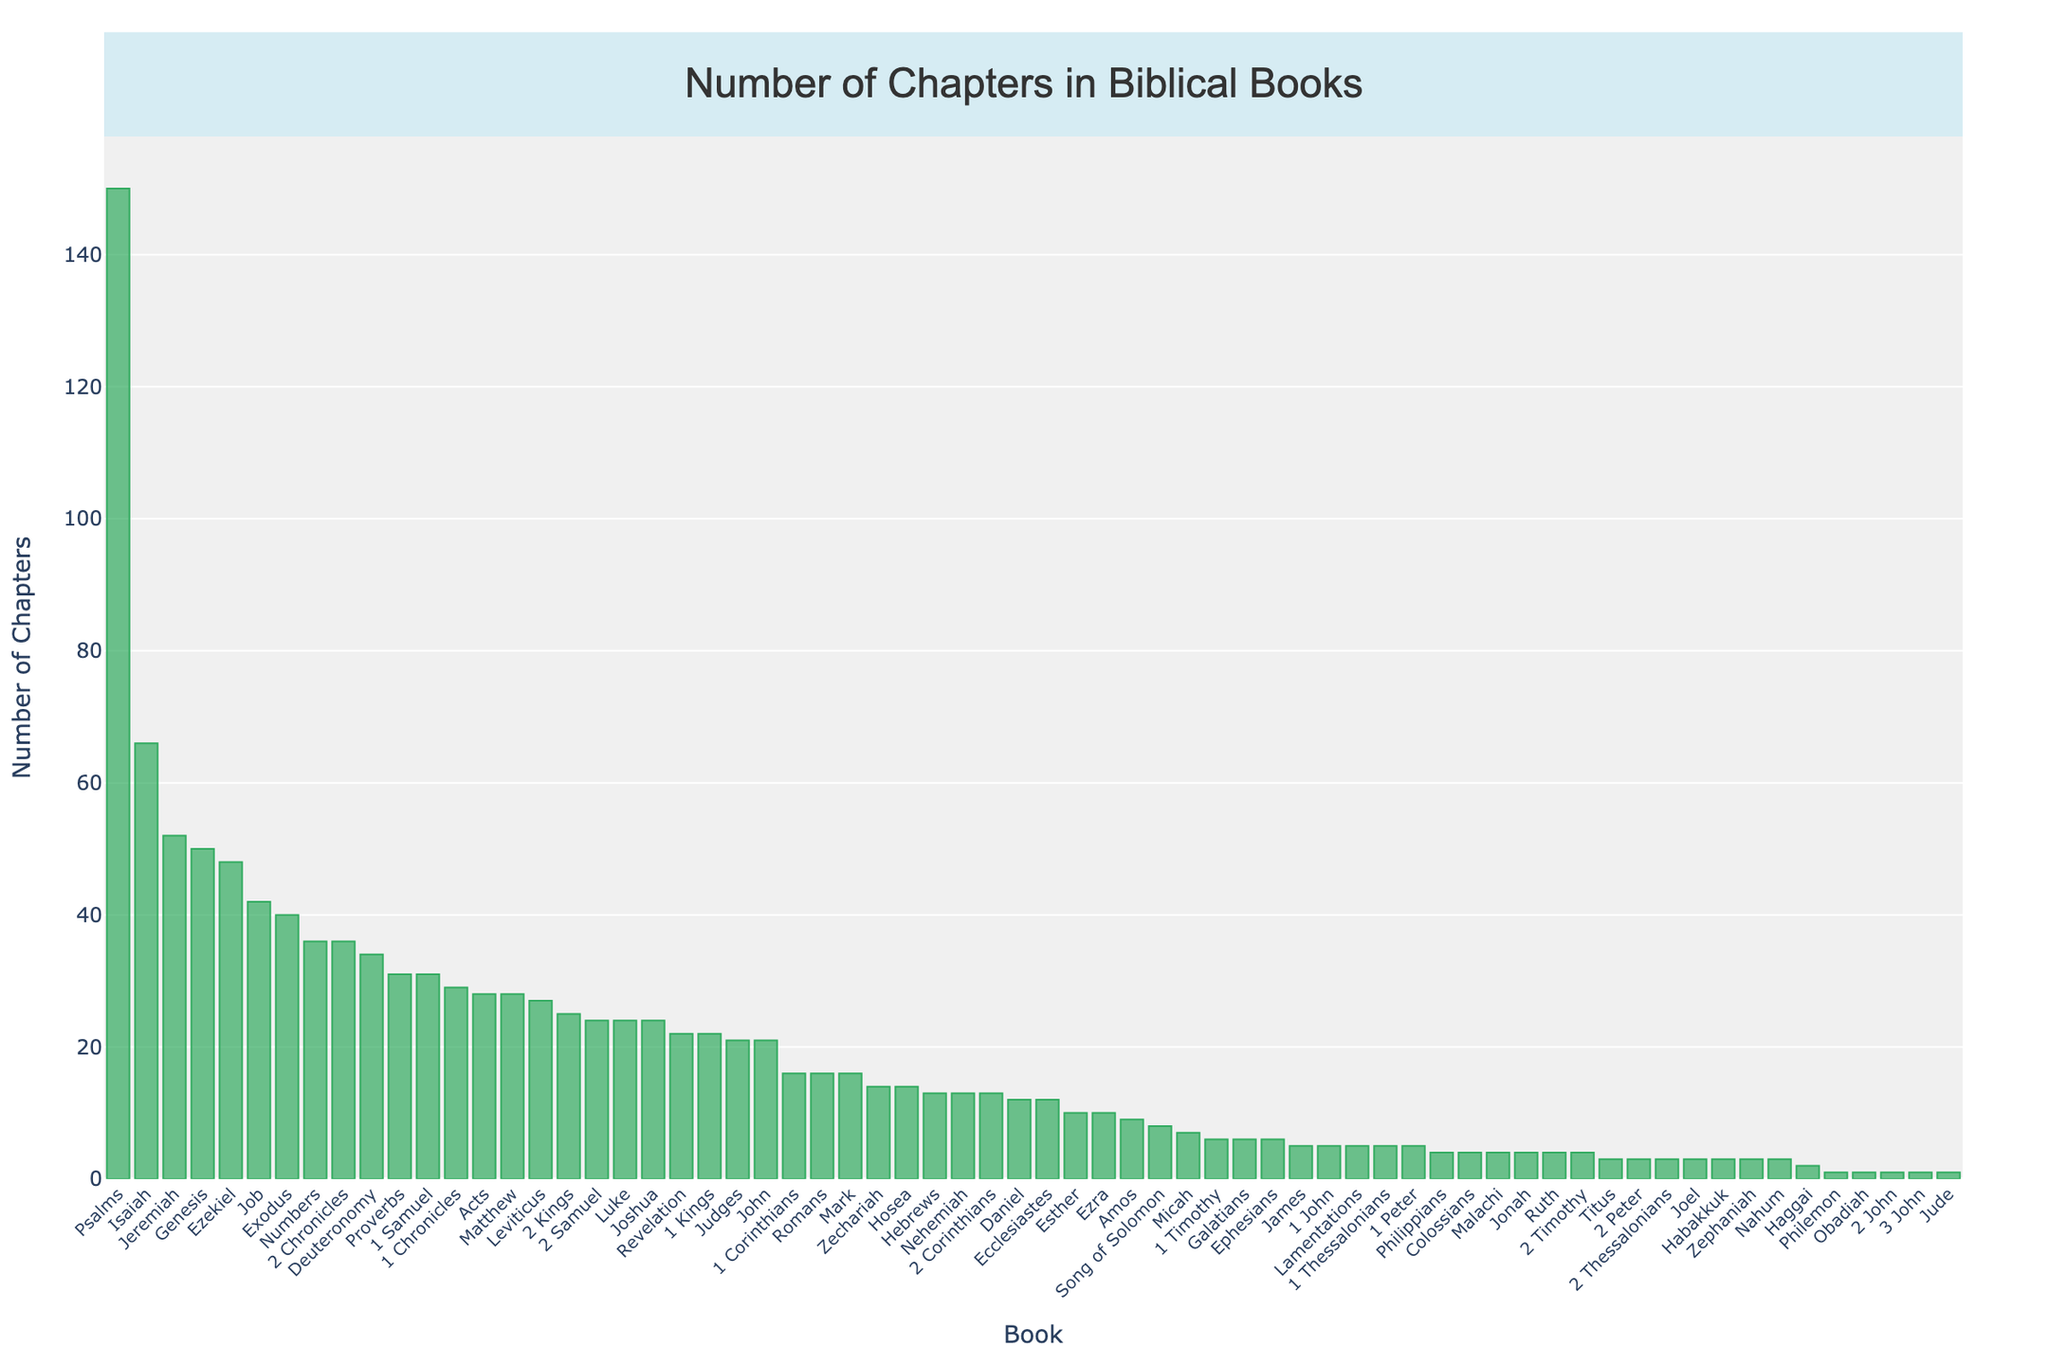Which book has the highest number of chapters? Looking at the highest bar in the chart, we identify Psalms as the book with the largest number of chapters, which is 150.
Answer: Psalms Which book has more chapters, Isaiah or Jeremiah? Compare the heights of the bars for Isaiah and Jeremiah. Isaiah has 66 chapters, and Jeremiah has 52 chapters. Therefore, Isaiah has more chapters.
Answer: Isaiah How many books have more than 40 chapters? Count the bars that have a height representing more than 40 chapters. The books are Genesis, Exodus, Job, Isaiah, Jeremiah, Ezekiel, and Psalms, making a total of 7 books.
Answer: 7 How many chapters are there in total across Joshua, Judges, and Ruth? Add the number of chapters in Joshua (24), Judges (21), and Ruth (4). So, 24 + 21 + 4 = 49.
Answer: 49 Which book has fewer chapters, Amos or Micah? Compare the heights of the bars for Amos and Micah. Amos has 9 chapters, while Micah has 7 chapters, so Micah has fewer chapters.
Answer: Micah What is the difference in the number of chapters between the book of Acts and the book of Romans? Subtract the number of chapters in Romans (16) from the number of chapters in Acts (28). So, 28 - 16 = 12.
Answer: 12 What is the average number of chapters in the books of the New Testament shown in the figure? Identify the New Testament books and calculate the average. Add the number of chapters in the New Testament books from Matthew to Revelation and divide by the number of books. Total chapters = 334, number of books = 27, so the average is 334 / 27 = 12.37.
Answer: 12.37 Which book has the shortest number of chapters, and how many? Determine the book with the smallest bar, which represents the fewest chapters. Obadiah, Philemon, 2 John, 3 John, and Jude all have 1 chapter, making them the shortest.
Answer: Obadiah, Philemon, 2 John, 3 John, Jude (1 chapter each) How many books have exactly 4 chapters? Count the bars with a height corresponding to 4 chapters. The books are Ruth, Jonah, Colossians, and Malachi, making a total of 4 books.
Answer: 4 Is the number of chapters in Genesis greater than the sum of the chapters in Jonah and Haggai? Compare the number of chapters in Genesis (50) with the sum of the chapters in Jonah (4) and Haggai (2). 4 + 2 = 6, so 50 is greater than 6.
Answer: Yes 